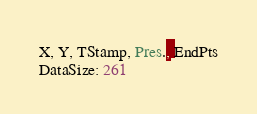<code> <loc_0><loc_0><loc_500><loc_500><_SML_>X, Y, TStamp, Pres., EndPts
DataSize: 261</code> 